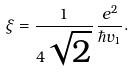<formula> <loc_0><loc_0><loc_500><loc_500>\xi = \frac { 1 } { 4 \sqrt { 2 } } \, \frac { e ^ { 2 } } { \hbar { v } _ { 1 } } .</formula> 